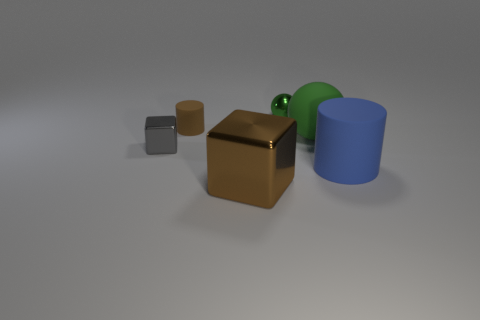Is the cylinder that is in front of the big green matte thing made of the same material as the big brown object?
Offer a very short reply. No. Are there the same number of cylinders that are on the right side of the small green sphere and small shiny objects that are on the right side of the brown metallic block?
Your answer should be compact. Yes. What shape is the large object that is both on the right side of the tiny metal ball and left of the large blue rubber object?
Your response must be concise. Sphere. There is a blue rubber cylinder; what number of large blue rubber cylinders are behind it?
Give a very brief answer. 0. How many other objects are the same shape as the small brown rubber object?
Offer a very short reply. 1. Are there fewer brown blocks than red shiny things?
Your answer should be very brief. No. What size is the matte thing that is both behind the gray cube and in front of the small matte cylinder?
Your answer should be compact. Large. What size is the brown block that is in front of the large matte thing left of the cylinder on the right side of the tiny green object?
Your response must be concise. Large. What is the size of the brown metallic thing?
Ensure brevity in your answer.  Large. Are there any other things that are made of the same material as the brown cylinder?
Provide a succinct answer. Yes. 